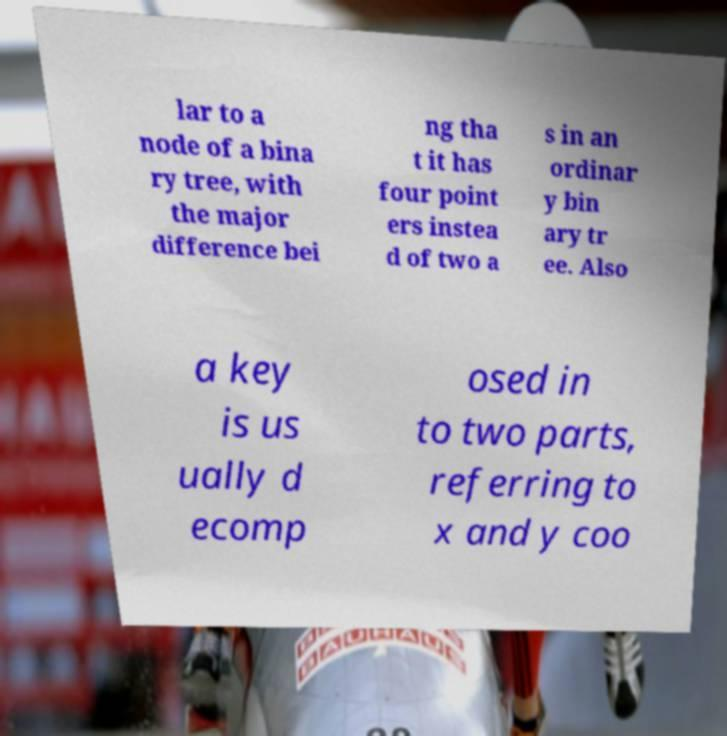For documentation purposes, I need the text within this image transcribed. Could you provide that? lar to a node of a bina ry tree, with the major difference bei ng tha t it has four point ers instea d of two a s in an ordinar y bin ary tr ee. Also a key is us ually d ecomp osed in to two parts, referring to x and y coo 